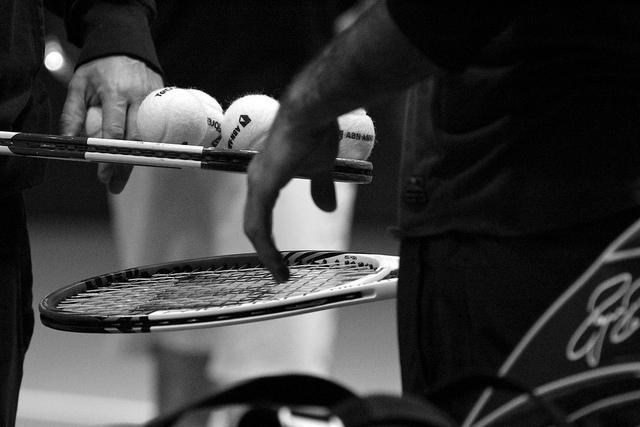What are the balls sitting on?
Short answer required. Racquet. Are the people most likely males or females?
Short answer required. Males. How many balls in this picture?
Answer briefly. 5. 